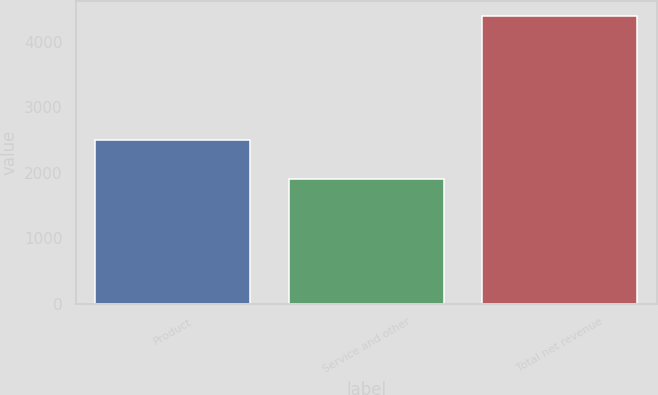Convert chart to OTSL. <chart><loc_0><loc_0><loc_500><loc_500><bar_chart><fcel>Product<fcel>Service and other<fcel>Total net revenue<nl><fcel>2497<fcel>1899<fcel>4396<nl></chart> 